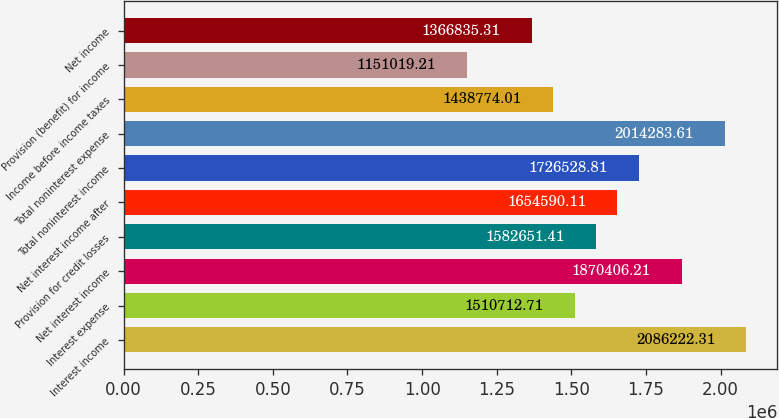Convert chart. <chart><loc_0><loc_0><loc_500><loc_500><bar_chart><fcel>Interest income<fcel>Interest expense<fcel>Net interest income<fcel>Provision for credit losses<fcel>Net interest income after<fcel>Total noninterest income<fcel>Total noninterest expense<fcel>Income before income taxes<fcel>Provision (benefit) for income<fcel>Net income<nl><fcel>2.08622e+06<fcel>1.51071e+06<fcel>1.87041e+06<fcel>1.58265e+06<fcel>1.65459e+06<fcel>1.72653e+06<fcel>2.01428e+06<fcel>1.43877e+06<fcel>1.15102e+06<fcel>1.36684e+06<nl></chart> 